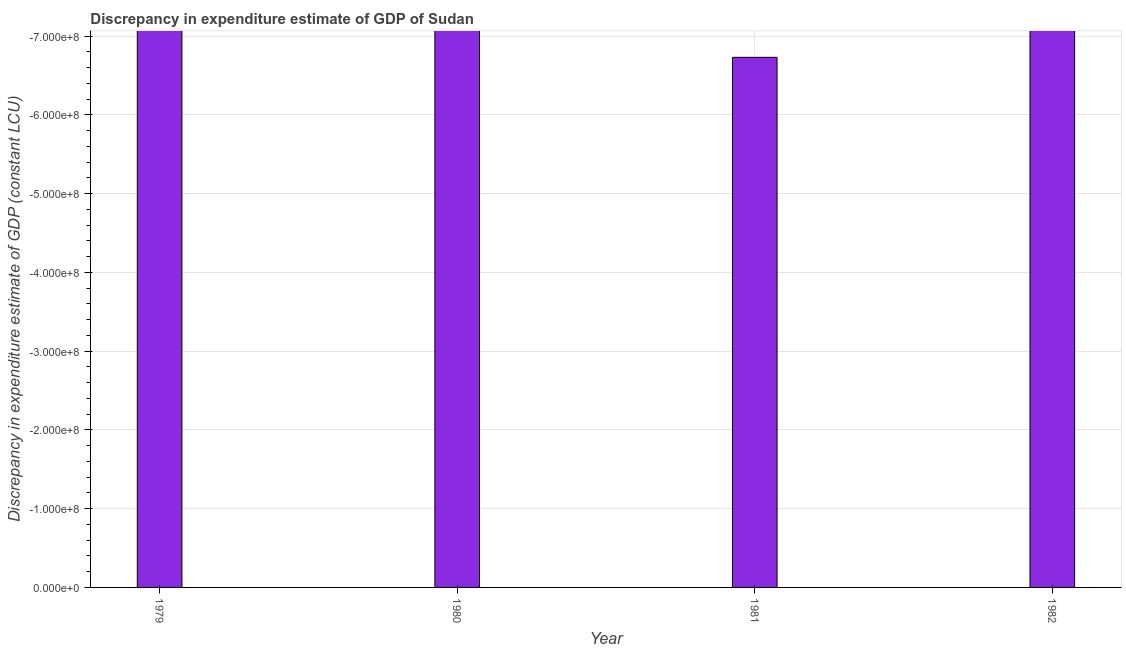What is the title of the graph?
Ensure brevity in your answer.  Discrepancy in expenditure estimate of GDP of Sudan. What is the label or title of the X-axis?
Make the answer very short. Year. What is the label or title of the Y-axis?
Your answer should be very brief. Discrepancy in expenditure estimate of GDP (constant LCU). What is the discrepancy in expenditure estimate of gdp in 1980?
Provide a short and direct response. 0. Across all years, what is the minimum discrepancy in expenditure estimate of gdp?
Offer a very short reply. 0. In how many years, is the discrepancy in expenditure estimate of gdp greater than -520000000 LCU?
Provide a short and direct response. 0. In how many years, is the discrepancy in expenditure estimate of gdp greater than the average discrepancy in expenditure estimate of gdp taken over all years?
Make the answer very short. 0. How many bars are there?
Offer a terse response. 0. Are the values on the major ticks of Y-axis written in scientific E-notation?
Give a very brief answer. Yes. What is the Discrepancy in expenditure estimate of GDP (constant LCU) in 1981?
Offer a terse response. 0. 